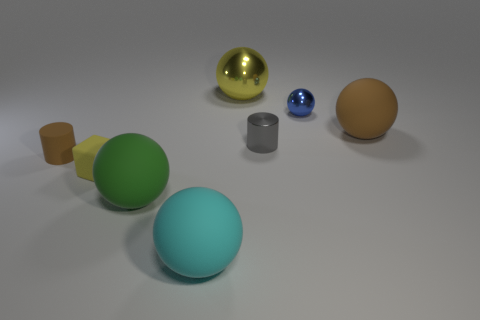Subtract all brown matte balls. How many balls are left? 4 Add 2 big green rubber spheres. How many objects exist? 10 Subtract 3 balls. How many balls are left? 2 Subtract all cylinders. How many objects are left? 6 Subtract all gray cylinders. How many cylinders are left? 1 Subtract all red spheres. Subtract all blue cubes. How many spheres are left? 5 Subtract all red balls. Subtract all brown rubber cylinders. How many objects are left? 7 Add 7 small yellow cubes. How many small yellow cubes are left? 8 Add 3 small blue shiny blocks. How many small blue shiny blocks exist? 3 Subtract 0 cyan cylinders. How many objects are left? 8 